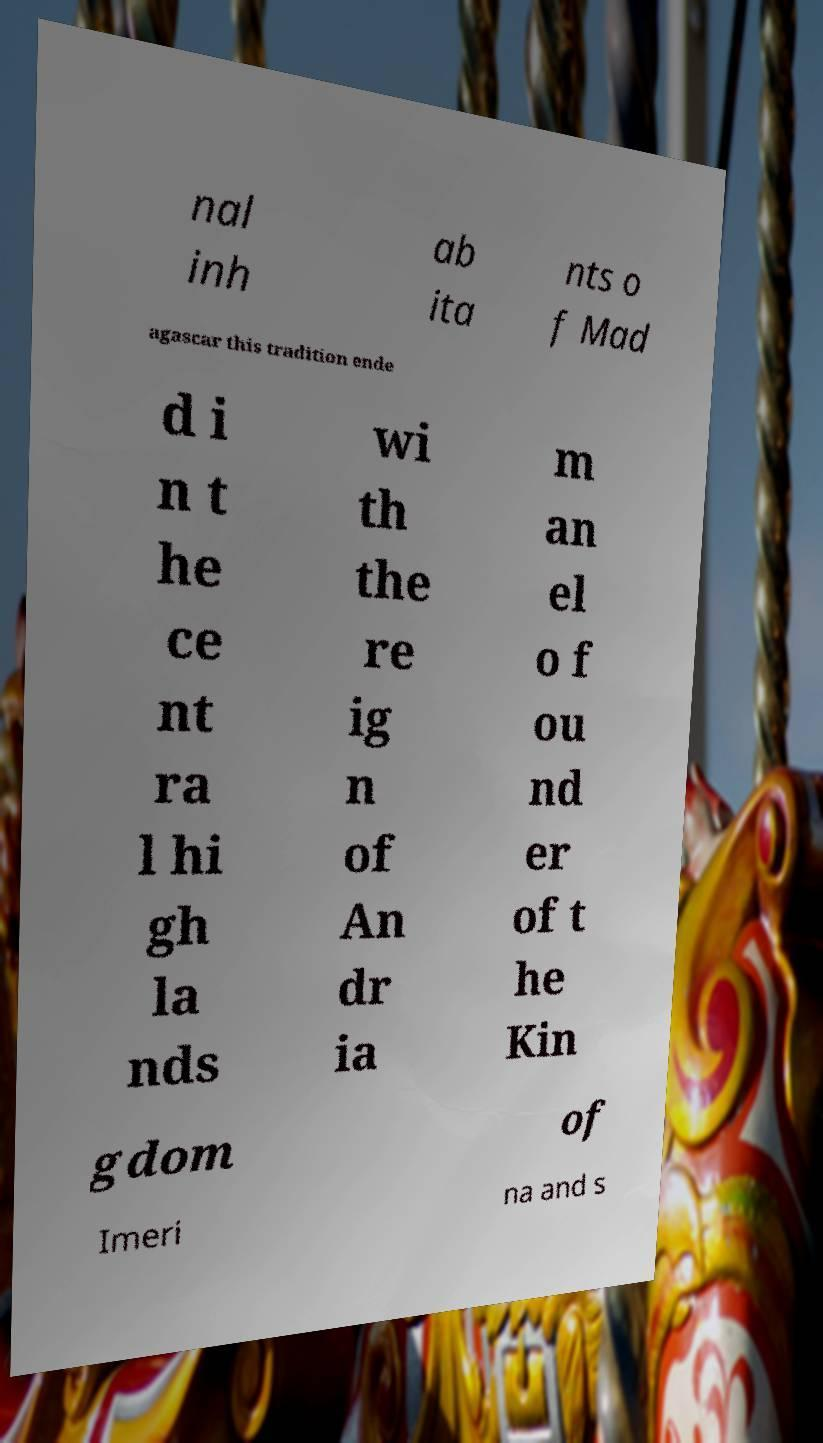For documentation purposes, I need the text within this image transcribed. Could you provide that? nal inh ab ita nts o f Mad agascar this tradition ende d i n t he ce nt ra l hi gh la nds wi th the re ig n of An dr ia m an el o f ou nd er of t he Kin gdom of Imeri na and s 